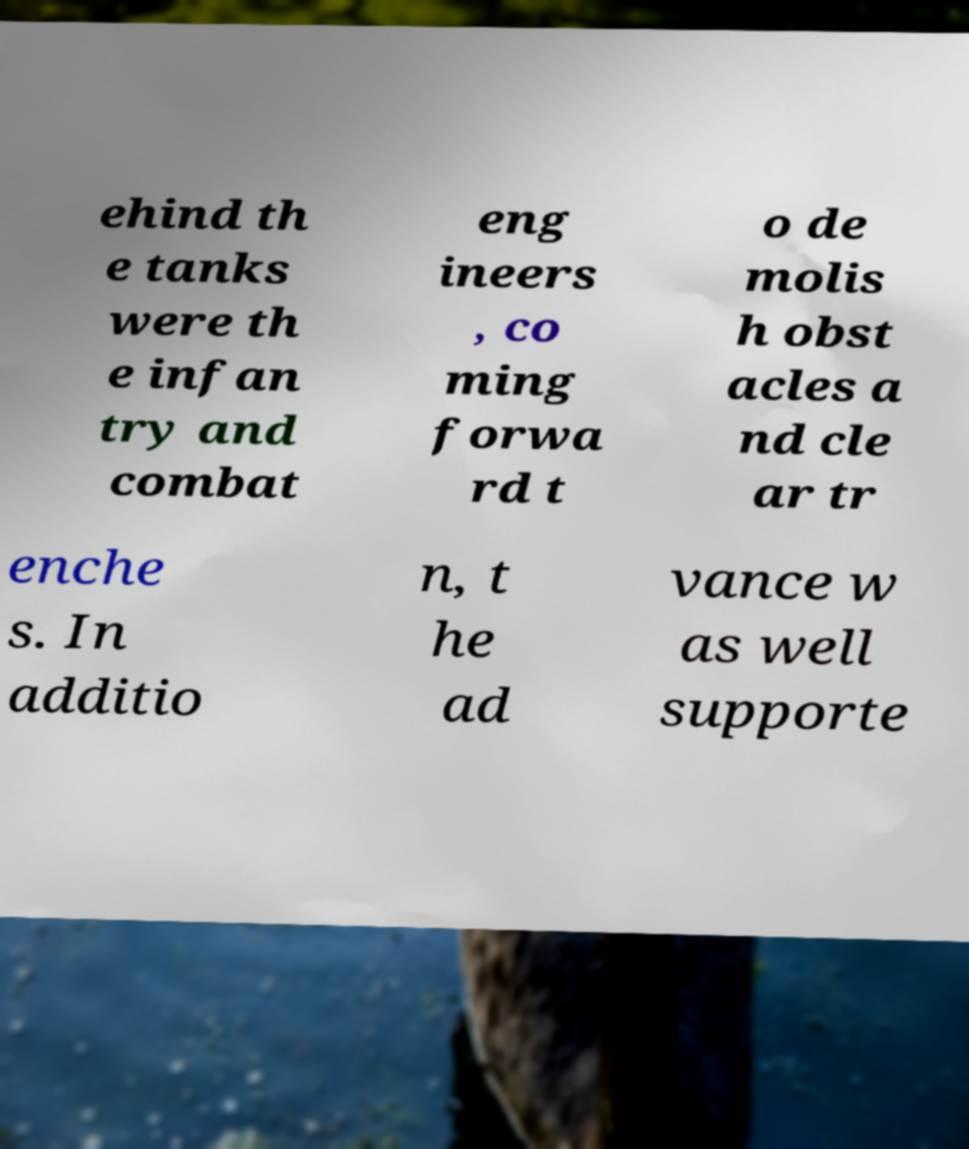Please identify and transcribe the text found in this image. ehind th e tanks were th e infan try and combat eng ineers , co ming forwa rd t o de molis h obst acles a nd cle ar tr enche s. In additio n, t he ad vance w as well supporte 